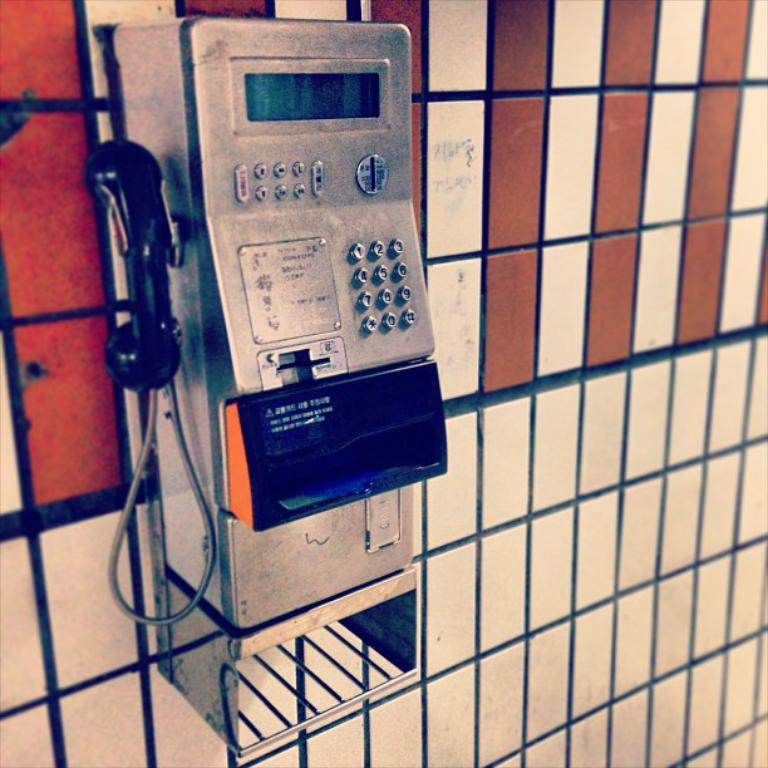What object can be seen in the image that is used for communication? There is a telephone in the image. Where is the telephone located in the image? The telephone is mounted on the wall. What type of punishment is being administered through the telephone in the image? There is no punishment being administered through the telephone in the image; it is simply a communication device mounted on the wall. 